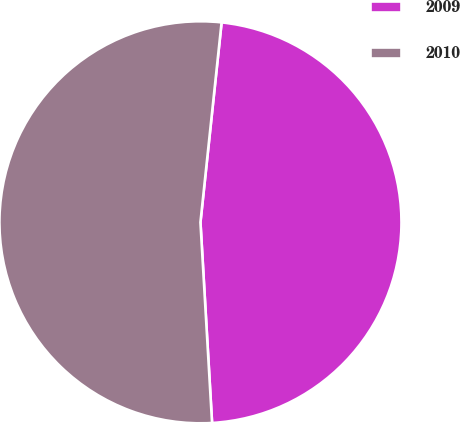<chart> <loc_0><loc_0><loc_500><loc_500><pie_chart><fcel>2009<fcel>2010<nl><fcel>47.4%<fcel>52.6%<nl></chart> 